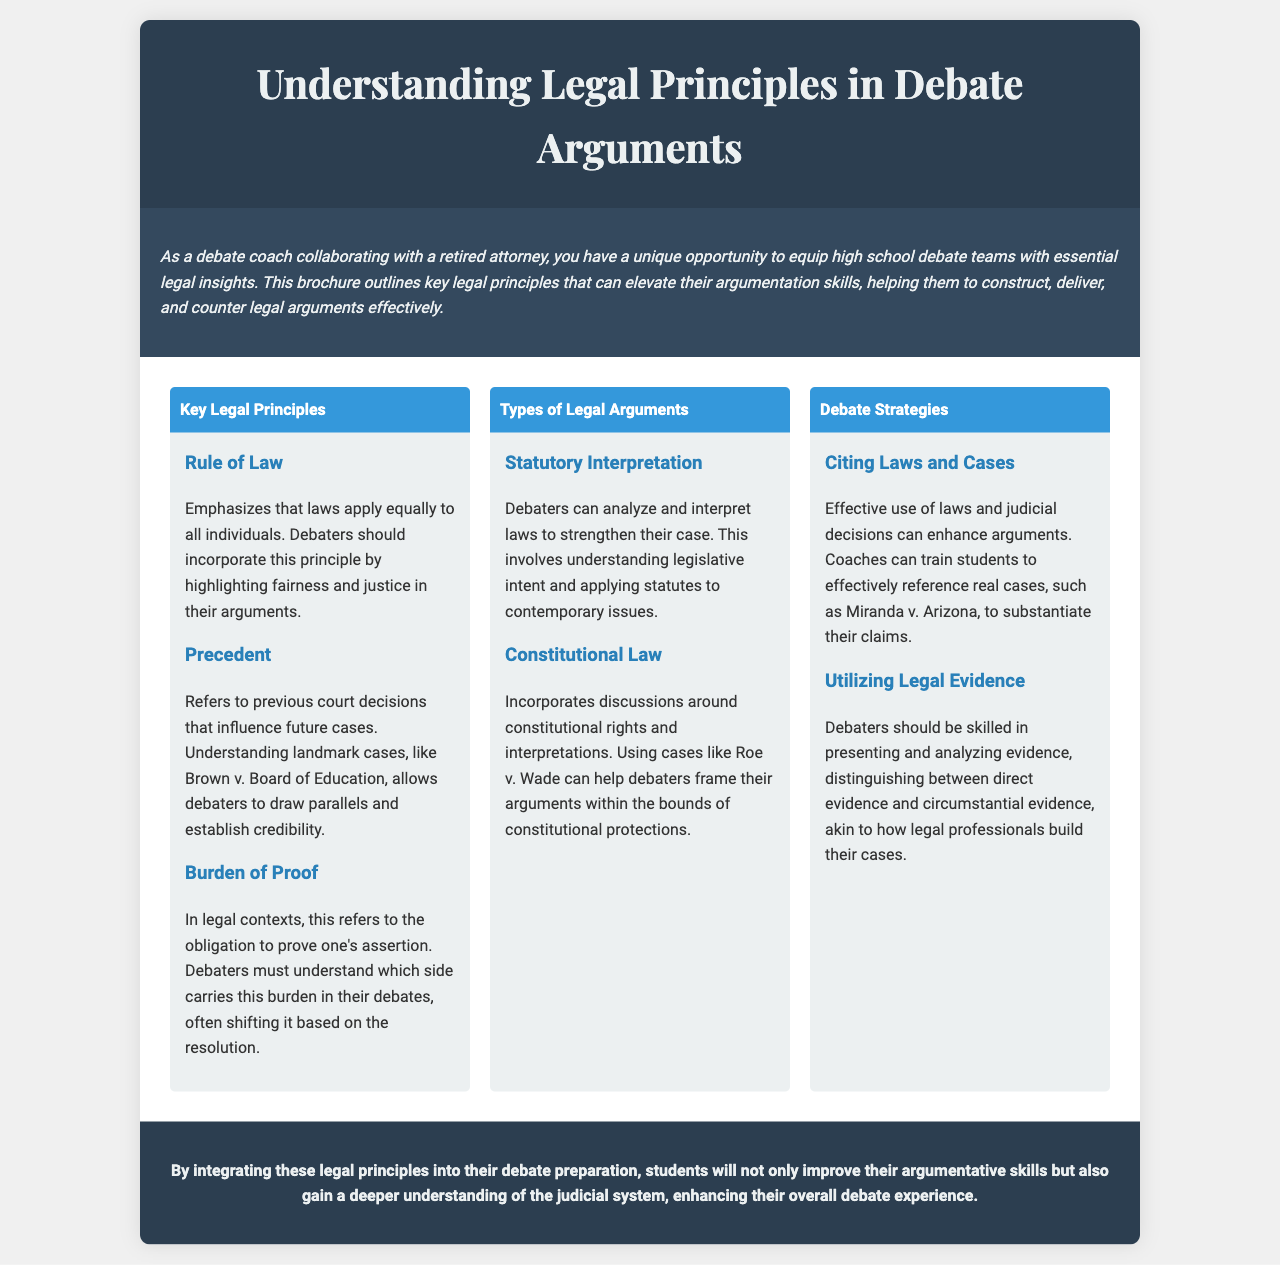What is the main topic of the brochure? The main topic is outlined in the title of the brochure, which explains what it covers.
Answer: Understanding Legal Principles in Debate Arguments Who is the target audience of this brochure? The document specifies that it is intended for a particular group interested in legal insights for debate.
Answer: High school debate teams What landmark case is mentioned as an example of precedent? The document refers to an important court case that serves as a significant reference in legal arguments.
Answer: Brown v. Board of Education What legal principle emphasizes fairness and justice? The document discusses key legal principles, and one of them focuses on equality before the law.
Answer: Rule of Law What types of arguments can debaters analyze according to this brochure? The brochure specifies various categories of legal arguments that can be used in debates.
Answer: Statutory Interpretation and Constitutional Law What is the purpose of citing laws and cases in debate? The brochure outlines why incorporating legal references is vital for constructing strong arguments.
Answer: To enhance arguments What two types of evidence should debaters distinguish between? The document states the types of evidence that should be recognized when presenting legal cases.
Answer: Direct evidence and circumstantial evidence How does the brochure suggest that students improve their argumentative skills? The document provides a recommendation for integrating certain concepts into debate practice.
Answer: By integrating legal principles What is stated in the conclusion regarding students' understanding? The conclusion summarizes the overall benefit of applying the discussed principles in debate preparation.
Answer: A deeper understanding of the judicial system 